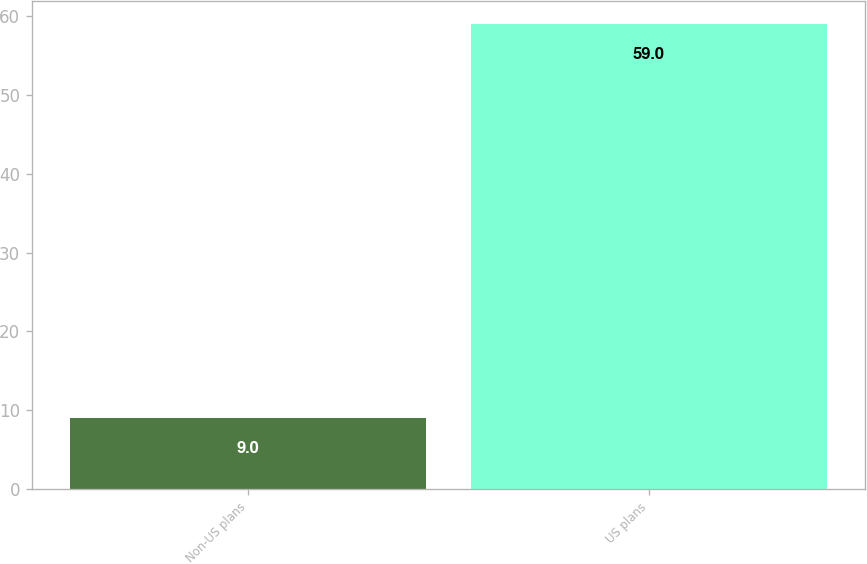Convert chart to OTSL. <chart><loc_0><loc_0><loc_500><loc_500><bar_chart><fcel>Non-US plans<fcel>US plans<nl><fcel>9<fcel>59<nl></chart> 